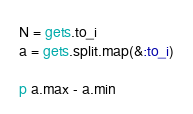Convert code to text. <code><loc_0><loc_0><loc_500><loc_500><_Ruby_>N = gets.to_i
a = gets.split.map(&:to_i)

p a.max - a.min</code> 